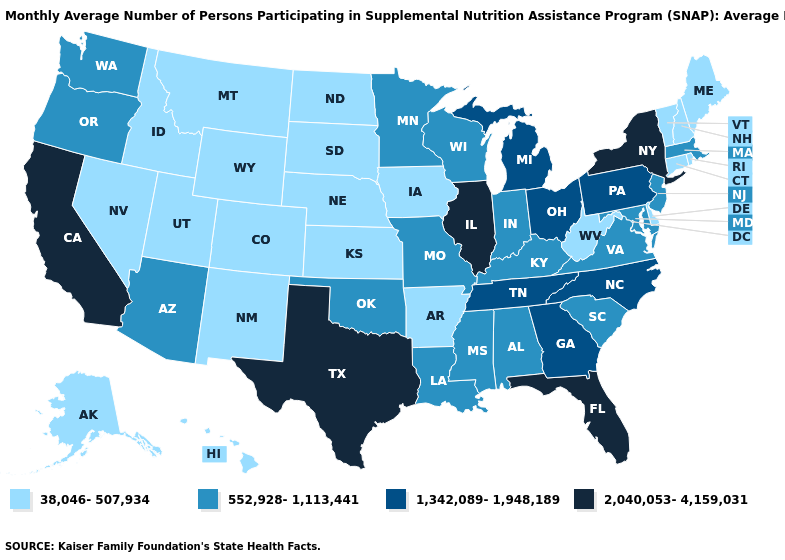What is the lowest value in the USA?
Give a very brief answer. 38,046-507,934. What is the value of Alaska?
Answer briefly. 38,046-507,934. What is the highest value in the USA?
Write a very short answer. 2,040,053-4,159,031. Does the map have missing data?
Quick response, please. No. Is the legend a continuous bar?
Write a very short answer. No. Name the states that have a value in the range 2,040,053-4,159,031?
Write a very short answer. California, Florida, Illinois, New York, Texas. Which states have the lowest value in the USA?
Quick response, please. Alaska, Arkansas, Colorado, Connecticut, Delaware, Hawaii, Idaho, Iowa, Kansas, Maine, Montana, Nebraska, Nevada, New Hampshire, New Mexico, North Dakota, Rhode Island, South Dakota, Utah, Vermont, West Virginia, Wyoming. What is the highest value in the West ?
Answer briefly. 2,040,053-4,159,031. Among the states that border Oregon , which have the highest value?
Give a very brief answer. California. Does the map have missing data?
Be succinct. No. What is the highest value in the West ?
Write a very short answer. 2,040,053-4,159,031. Does Nebraska have the lowest value in the MidWest?
Concise answer only. Yes. Name the states that have a value in the range 1,342,089-1,948,189?
Be succinct. Georgia, Michigan, North Carolina, Ohio, Pennsylvania, Tennessee. Name the states that have a value in the range 38,046-507,934?
Give a very brief answer. Alaska, Arkansas, Colorado, Connecticut, Delaware, Hawaii, Idaho, Iowa, Kansas, Maine, Montana, Nebraska, Nevada, New Hampshire, New Mexico, North Dakota, Rhode Island, South Dakota, Utah, Vermont, West Virginia, Wyoming. Name the states that have a value in the range 1,342,089-1,948,189?
Short answer required. Georgia, Michigan, North Carolina, Ohio, Pennsylvania, Tennessee. 